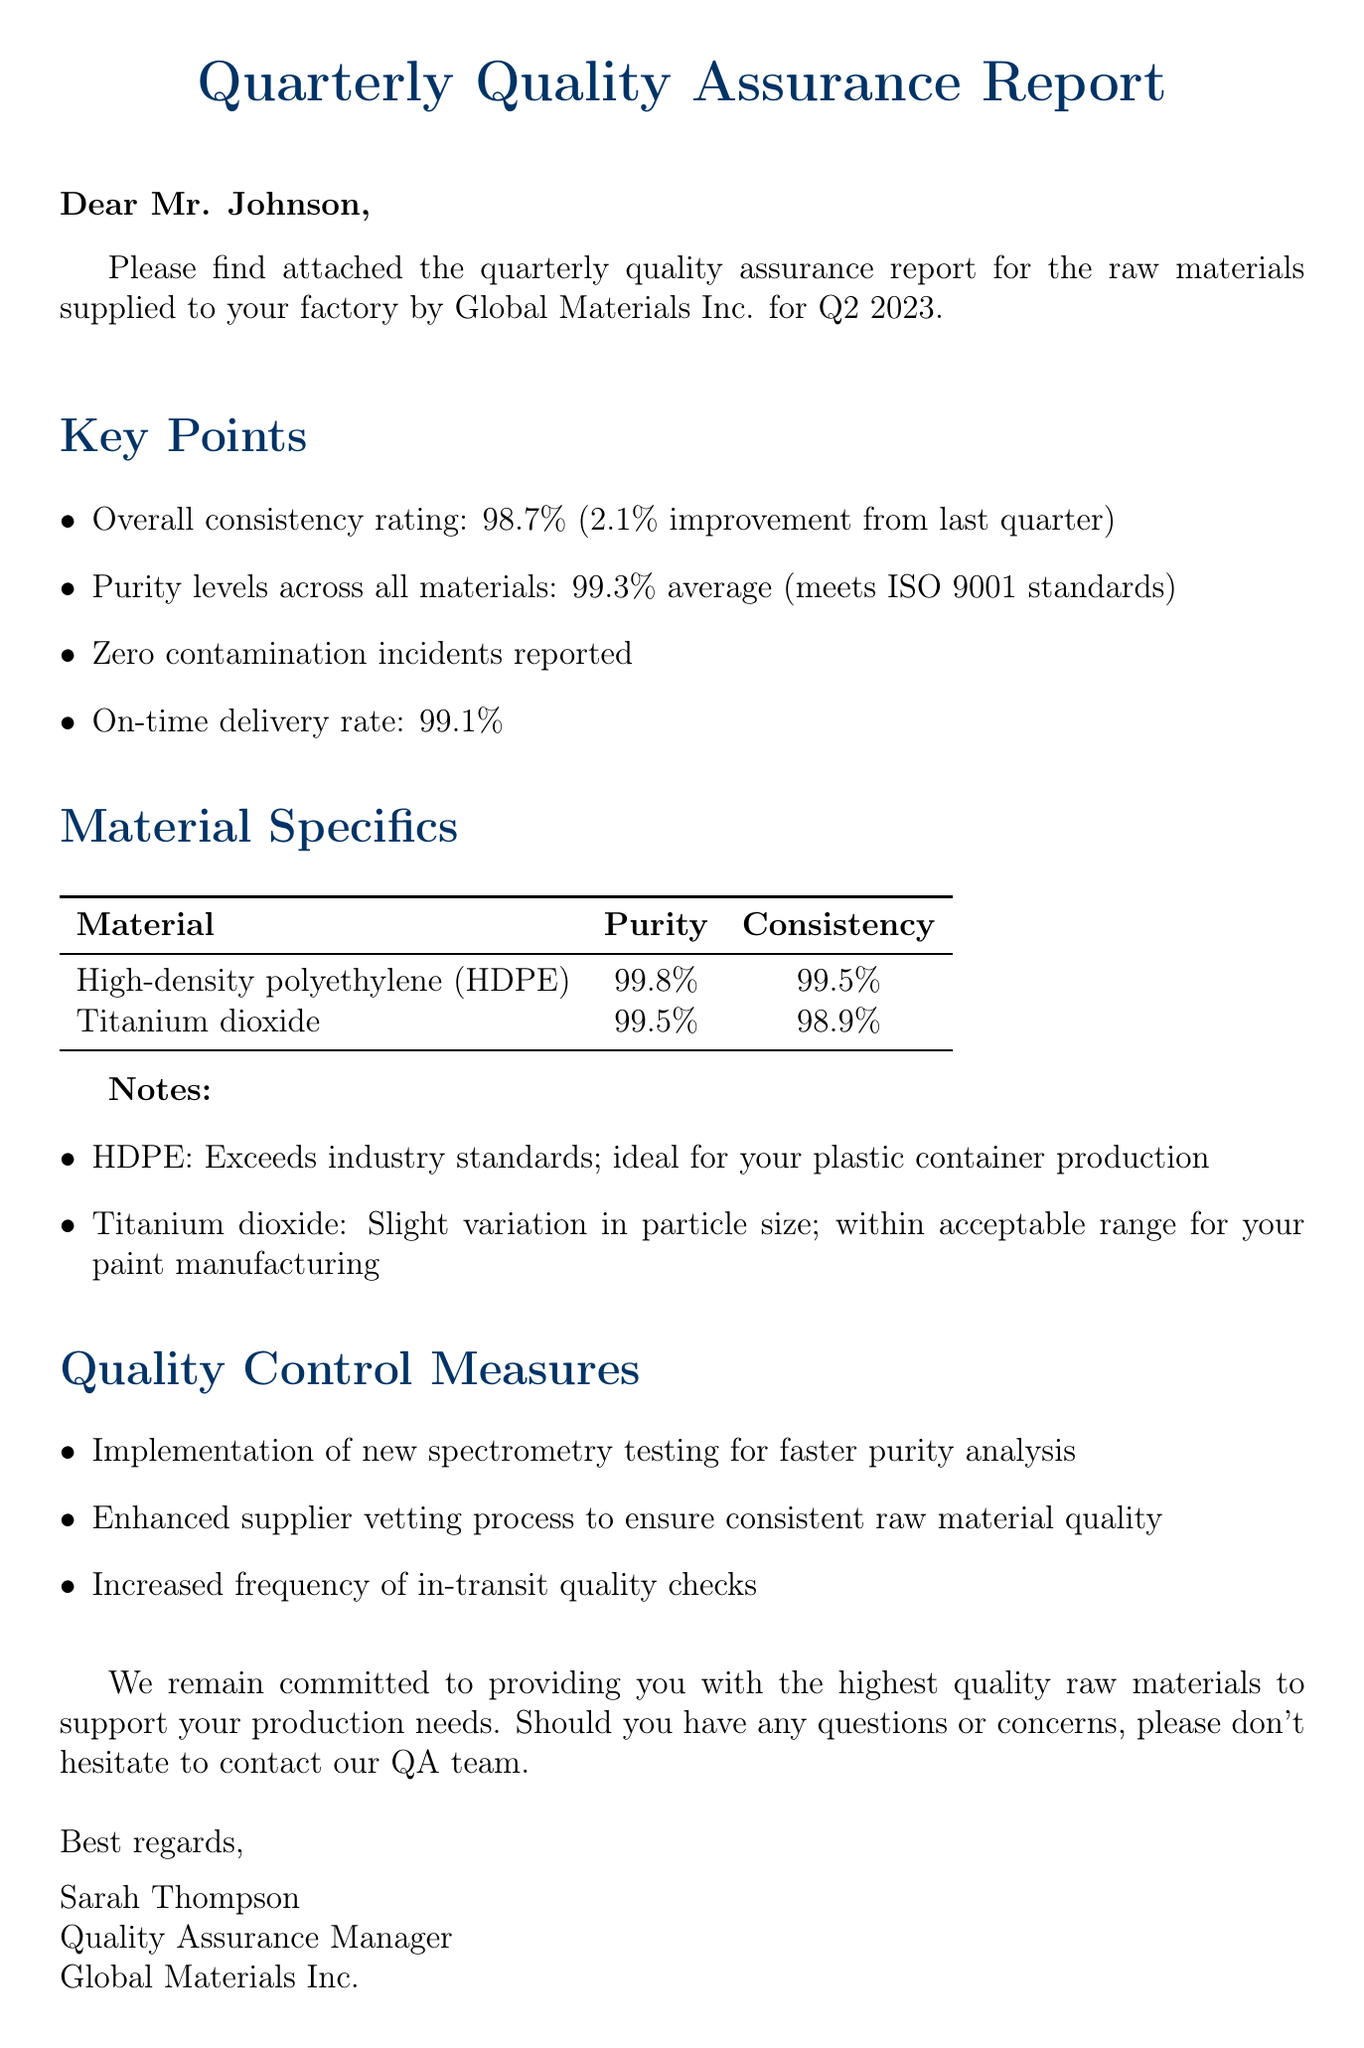What is the overall consistency rating for Q2 2023? The overall consistency rating indicated in the report is stated clearly, showing a figure of 98.7%.
Answer: 98.7% What is the average purity level of the supplied materials? The average purity level across all materials is specified in the report as 99.3%.
Answer: 99.3% Was there any contamination incident reported during Q2 2023? The report mentions zero contamination incidents, confirming the quality of the supplied materials.
Answer: Zero What is the on-time delivery rate? The document provides a specific percentage for the on-time delivery rate, which is stated as 99.1%.
Answer: 99.1% What was the improvement in overall consistency rating from last quarter? The report specifies the improvement in the consistency rating as 2.1%, providing a clear comparative figure.
Answer: 2.1% Which material has the highest purity level? The material specific section lists the purity levels, and HDPE has the highest at 99.8%.
Answer: High-density polyethylene (HDPE) What are the quality control measures implemented? The document outlines enhanced quality control measures, particularly focusing on spectrometry testing and vetting processes.
Answer: New spectrometry testing, enhanced supplier vetting, increased frequency of in-transit quality checks What does the note for Titanium dioxide indicate? The note specifies that there is a slight variation in particle size for Titanium dioxide, which is acknowledged in the document.
Answer: Slight variation in particle size Who is the Quality Assurance Manager? The signature at the end of the document indicates the name of the Quality Assurance Manager.
Answer: Sarah Thompson 